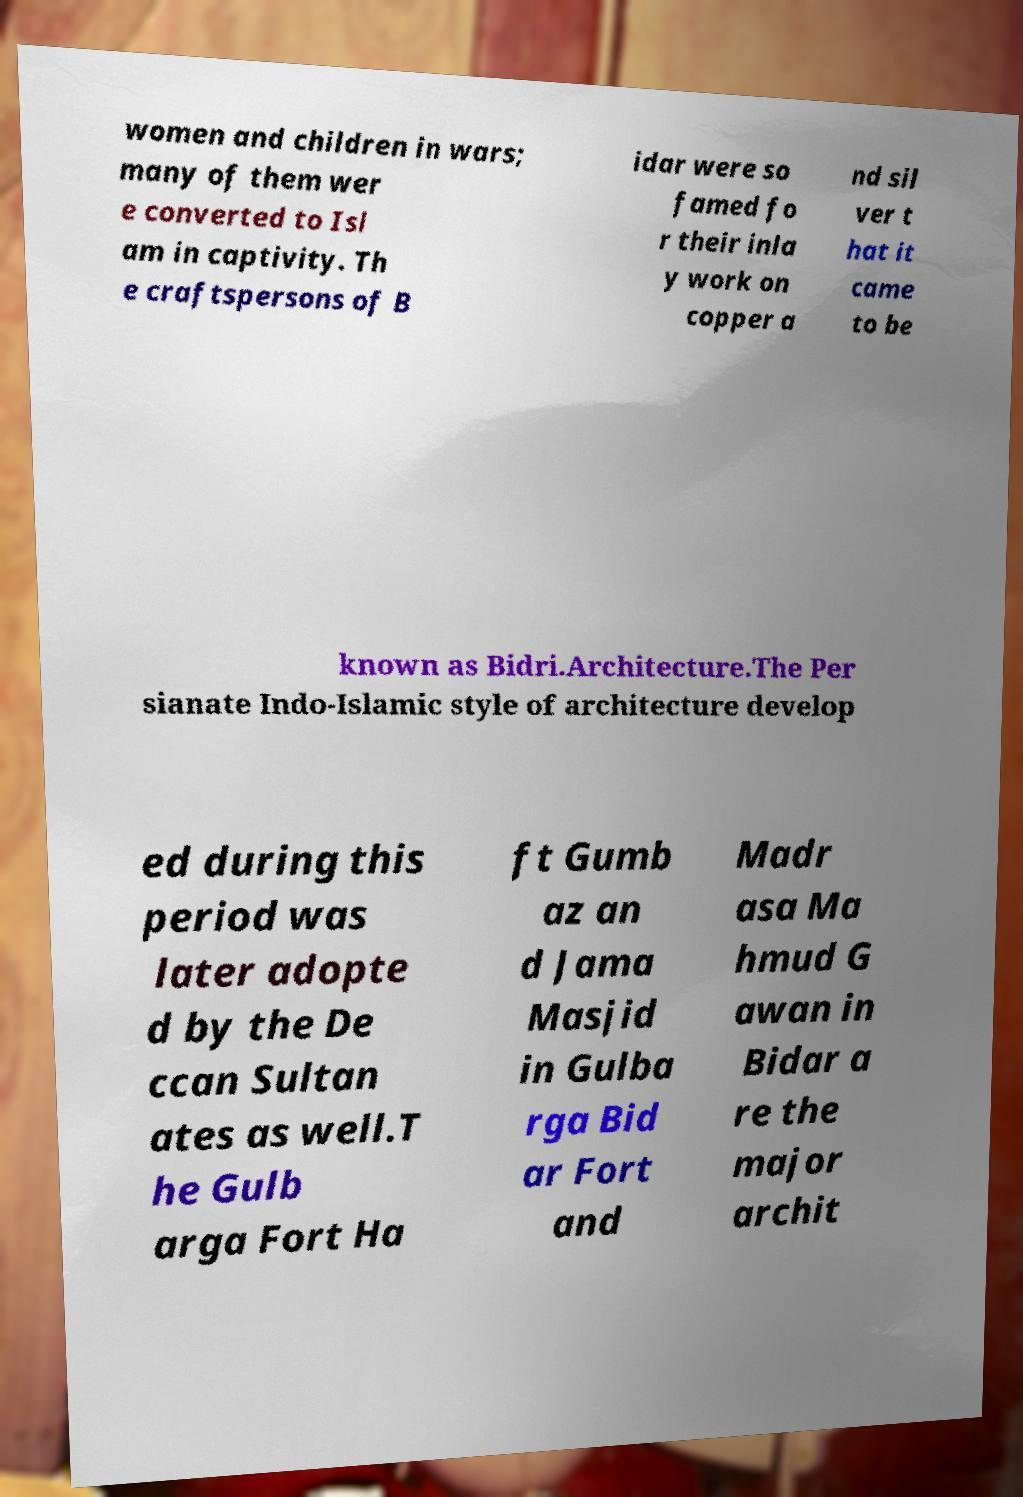I need the written content from this picture converted into text. Can you do that? women and children in wars; many of them wer e converted to Isl am in captivity. Th e craftspersons of B idar were so famed fo r their inla y work on copper a nd sil ver t hat it came to be known as Bidri.Architecture.The Per sianate Indo-Islamic style of architecture develop ed during this period was later adopte d by the De ccan Sultan ates as well.T he Gulb arga Fort Ha ft Gumb az an d Jama Masjid in Gulba rga Bid ar Fort and Madr asa Ma hmud G awan in Bidar a re the major archit 